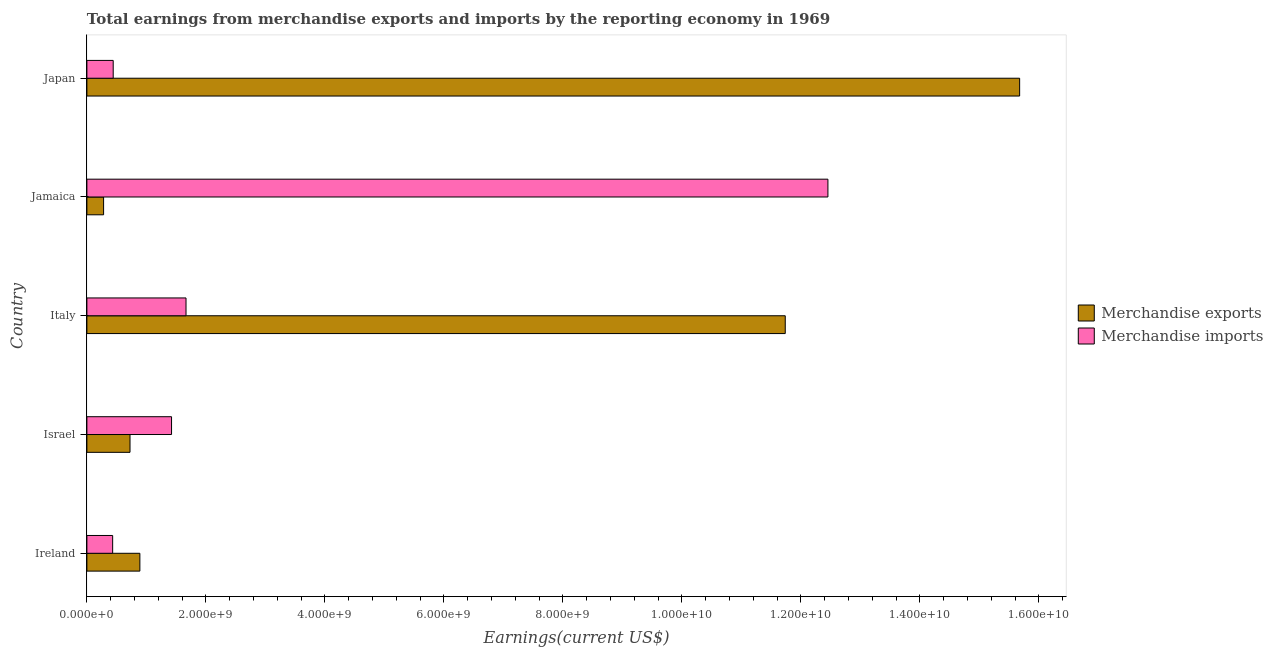How many groups of bars are there?
Provide a succinct answer. 5. Are the number of bars per tick equal to the number of legend labels?
Your response must be concise. Yes. How many bars are there on the 3rd tick from the bottom?
Give a very brief answer. 2. What is the label of the 2nd group of bars from the top?
Provide a succinct answer. Jamaica. In how many cases, is the number of bars for a given country not equal to the number of legend labels?
Make the answer very short. 0. What is the earnings from merchandise imports in Italy?
Provide a succinct answer. 1.67e+09. Across all countries, what is the maximum earnings from merchandise exports?
Your answer should be very brief. 1.57e+1. Across all countries, what is the minimum earnings from merchandise exports?
Offer a terse response. 2.81e+08. In which country was the earnings from merchandise exports minimum?
Provide a succinct answer. Jamaica. What is the total earnings from merchandise imports in the graph?
Provide a short and direct response. 1.64e+1. What is the difference between the earnings from merchandise imports in Ireland and that in Italy?
Keep it short and to the point. -1.23e+09. What is the difference between the earnings from merchandise exports in Japan and the earnings from merchandise imports in Ireland?
Your answer should be very brief. 1.52e+1. What is the average earnings from merchandise imports per country?
Your answer should be very brief. 3.28e+09. What is the difference between the earnings from merchandise imports and earnings from merchandise exports in Ireland?
Your answer should be compact. -4.57e+08. In how many countries, is the earnings from merchandise imports greater than 7200000000 US$?
Make the answer very short. 1. What is the ratio of the earnings from merchandise imports in Israel to that in Japan?
Your answer should be compact. 3.22. Is the earnings from merchandise exports in Jamaica less than that in Japan?
Ensure brevity in your answer.  Yes. What is the difference between the highest and the second highest earnings from merchandise exports?
Your answer should be very brief. 3.94e+09. What is the difference between the highest and the lowest earnings from merchandise exports?
Keep it short and to the point. 1.54e+1. Is the sum of the earnings from merchandise imports in Jamaica and Japan greater than the maximum earnings from merchandise exports across all countries?
Make the answer very short. No. What does the 1st bar from the top in Japan represents?
Make the answer very short. Merchandise imports. How many bars are there?
Keep it short and to the point. 10. Does the graph contain any zero values?
Provide a short and direct response. No. Where does the legend appear in the graph?
Make the answer very short. Center right. How many legend labels are there?
Give a very brief answer. 2. How are the legend labels stacked?
Offer a very short reply. Vertical. What is the title of the graph?
Your answer should be compact. Total earnings from merchandise exports and imports by the reporting economy in 1969. Does "Fertility rate" appear as one of the legend labels in the graph?
Give a very brief answer. No. What is the label or title of the X-axis?
Offer a terse response. Earnings(current US$). What is the label or title of the Y-axis?
Offer a very short reply. Country. What is the Earnings(current US$) of Merchandise exports in Ireland?
Your answer should be compact. 8.90e+08. What is the Earnings(current US$) in Merchandise imports in Ireland?
Provide a succinct answer. 4.33e+08. What is the Earnings(current US$) in Merchandise exports in Israel?
Provide a short and direct response. 7.25e+08. What is the Earnings(current US$) of Merchandise imports in Israel?
Your answer should be compact. 1.42e+09. What is the Earnings(current US$) in Merchandise exports in Italy?
Offer a terse response. 1.17e+1. What is the Earnings(current US$) in Merchandise imports in Italy?
Offer a terse response. 1.67e+09. What is the Earnings(current US$) of Merchandise exports in Jamaica?
Give a very brief answer. 2.81e+08. What is the Earnings(current US$) in Merchandise imports in Jamaica?
Your answer should be very brief. 1.25e+1. What is the Earnings(current US$) in Merchandise exports in Japan?
Ensure brevity in your answer.  1.57e+1. What is the Earnings(current US$) of Merchandise imports in Japan?
Make the answer very short. 4.42e+08. Across all countries, what is the maximum Earnings(current US$) in Merchandise exports?
Offer a very short reply. 1.57e+1. Across all countries, what is the maximum Earnings(current US$) in Merchandise imports?
Offer a terse response. 1.25e+1. Across all countries, what is the minimum Earnings(current US$) in Merchandise exports?
Your answer should be compact. 2.81e+08. Across all countries, what is the minimum Earnings(current US$) of Merchandise imports?
Provide a succinct answer. 4.33e+08. What is the total Earnings(current US$) in Merchandise exports in the graph?
Your answer should be very brief. 2.93e+1. What is the total Earnings(current US$) in Merchandise imports in the graph?
Offer a terse response. 1.64e+1. What is the difference between the Earnings(current US$) of Merchandise exports in Ireland and that in Israel?
Provide a succinct answer. 1.66e+08. What is the difference between the Earnings(current US$) of Merchandise imports in Ireland and that in Israel?
Offer a very short reply. -9.90e+08. What is the difference between the Earnings(current US$) of Merchandise exports in Ireland and that in Italy?
Ensure brevity in your answer.  -1.08e+1. What is the difference between the Earnings(current US$) of Merchandise imports in Ireland and that in Italy?
Your response must be concise. -1.23e+09. What is the difference between the Earnings(current US$) in Merchandise exports in Ireland and that in Jamaica?
Your response must be concise. 6.10e+08. What is the difference between the Earnings(current US$) of Merchandise imports in Ireland and that in Jamaica?
Provide a short and direct response. -1.20e+1. What is the difference between the Earnings(current US$) of Merchandise exports in Ireland and that in Japan?
Your response must be concise. -1.48e+1. What is the difference between the Earnings(current US$) in Merchandise imports in Ireland and that in Japan?
Your response must be concise. -9.01e+06. What is the difference between the Earnings(current US$) of Merchandise exports in Israel and that in Italy?
Keep it short and to the point. -1.10e+1. What is the difference between the Earnings(current US$) of Merchandise imports in Israel and that in Italy?
Make the answer very short. -2.43e+08. What is the difference between the Earnings(current US$) in Merchandise exports in Israel and that in Jamaica?
Provide a succinct answer. 4.44e+08. What is the difference between the Earnings(current US$) in Merchandise imports in Israel and that in Jamaica?
Ensure brevity in your answer.  -1.10e+1. What is the difference between the Earnings(current US$) of Merchandise exports in Israel and that in Japan?
Your response must be concise. -1.50e+1. What is the difference between the Earnings(current US$) of Merchandise imports in Israel and that in Japan?
Provide a succinct answer. 9.81e+08. What is the difference between the Earnings(current US$) of Merchandise exports in Italy and that in Jamaica?
Your response must be concise. 1.15e+1. What is the difference between the Earnings(current US$) in Merchandise imports in Italy and that in Jamaica?
Provide a short and direct response. -1.08e+1. What is the difference between the Earnings(current US$) in Merchandise exports in Italy and that in Japan?
Offer a terse response. -3.94e+09. What is the difference between the Earnings(current US$) of Merchandise imports in Italy and that in Japan?
Your response must be concise. 1.22e+09. What is the difference between the Earnings(current US$) of Merchandise exports in Jamaica and that in Japan?
Give a very brief answer. -1.54e+1. What is the difference between the Earnings(current US$) in Merchandise imports in Jamaica and that in Japan?
Your answer should be very brief. 1.20e+1. What is the difference between the Earnings(current US$) of Merchandise exports in Ireland and the Earnings(current US$) of Merchandise imports in Israel?
Provide a short and direct response. -5.32e+08. What is the difference between the Earnings(current US$) in Merchandise exports in Ireland and the Earnings(current US$) in Merchandise imports in Italy?
Offer a very short reply. -7.76e+08. What is the difference between the Earnings(current US$) of Merchandise exports in Ireland and the Earnings(current US$) of Merchandise imports in Jamaica?
Make the answer very short. -1.16e+1. What is the difference between the Earnings(current US$) in Merchandise exports in Ireland and the Earnings(current US$) in Merchandise imports in Japan?
Your answer should be very brief. 4.48e+08. What is the difference between the Earnings(current US$) of Merchandise exports in Israel and the Earnings(current US$) of Merchandise imports in Italy?
Your answer should be compact. -9.41e+08. What is the difference between the Earnings(current US$) of Merchandise exports in Israel and the Earnings(current US$) of Merchandise imports in Jamaica?
Keep it short and to the point. -1.17e+1. What is the difference between the Earnings(current US$) in Merchandise exports in Israel and the Earnings(current US$) in Merchandise imports in Japan?
Make the answer very short. 2.83e+08. What is the difference between the Earnings(current US$) of Merchandise exports in Italy and the Earnings(current US$) of Merchandise imports in Jamaica?
Your response must be concise. -7.17e+08. What is the difference between the Earnings(current US$) of Merchandise exports in Italy and the Earnings(current US$) of Merchandise imports in Japan?
Keep it short and to the point. 1.13e+1. What is the difference between the Earnings(current US$) of Merchandise exports in Jamaica and the Earnings(current US$) of Merchandise imports in Japan?
Your answer should be compact. -1.61e+08. What is the average Earnings(current US$) in Merchandise exports per country?
Your answer should be very brief. 5.86e+09. What is the average Earnings(current US$) in Merchandise imports per country?
Make the answer very short. 3.28e+09. What is the difference between the Earnings(current US$) in Merchandise exports and Earnings(current US$) in Merchandise imports in Ireland?
Keep it short and to the point. 4.57e+08. What is the difference between the Earnings(current US$) in Merchandise exports and Earnings(current US$) in Merchandise imports in Israel?
Give a very brief answer. -6.98e+08. What is the difference between the Earnings(current US$) in Merchandise exports and Earnings(current US$) in Merchandise imports in Italy?
Provide a succinct answer. 1.01e+1. What is the difference between the Earnings(current US$) in Merchandise exports and Earnings(current US$) in Merchandise imports in Jamaica?
Make the answer very short. -1.22e+1. What is the difference between the Earnings(current US$) in Merchandise exports and Earnings(current US$) in Merchandise imports in Japan?
Your answer should be compact. 1.52e+1. What is the ratio of the Earnings(current US$) in Merchandise exports in Ireland to that in Israel?
Ensure brevity in your answer.  1.23. What is the ratio of the Earnings(current US$) in Merchandise imports in Ireland to that in Israel?
Your response must be concise. 0.3. What is the ratio of the Earnings(current US$) of Merchandise exports in Ireland to that in Italy?
Keep it short and to the point. 0.08. What is the ratio of the Earnings(current US$) of Merchandise imports in Ireland to that in Italy?
Keep it short and to the point. 0.26. What is the ratio of the Earnings(current US$) of Merchandise exports in Ireland to that in Jamaica?
Keep it short and to the point. 3.17. What is the ratio of the Earnings(current US$) in Merchandise imports in Ireland to that in Jamaica?
Offer a very short reply. 0.03. What is the ratio of the Earnings(current US$) of Merchandise exports in Ireland to that in Japan?
Keep it short and to the point. 0.06. What is the ratio of the Earnings(current US$) in Merchandise imports in Ireland to that in Japan?
Offer a very short reply. 0.98. What is the ratio of the Earnings(current US$) of Merchandise exports in Israel to that in Italy?
Provide a succinct answer. 0.06. What is the ratio of the Earnings(current US$) of Merchandise imports in Israel to that in Italy?
Make the answer very short. 0.85. What is the ratio of the Earnings(current US$) of Merchandise exports in Israel to that in Jamaica?
Your response must be concise. 2.58. What is the ratio of the Earnings(current US$) in Merchandise imports in Israel to that in Jamaica?
Ensure brevity in your answer.  0.11. What is the ratio of the Earnings(current US$) of Merchandise exports in Israel to that in Japan?
Ensure brevity in your answer.  0.05. What is the ratio of the Earnings(current US$) of Merchandise imports in Israel to that in Japan?
Give a very brief answer. 3.22. What is the ratio of the Earnings(current US$) of Merchandise exports in Italy to that in Jamaica?
Keep it short and to the point. 41.81. What is the ratio of the Earnings(current US$) in Merchandise imports in Italy to that in Jamaica?
Make the answer very short. 0.13. What is the ratio of the Earnings(current US$) of Merchandise exports in Italy to that in Japan?
Your answer should be very brief. 0.75. What is the ratio of the Earnings(current US$) of Merchandise imports in Italy to that in Japan?
Provide a short and direct response. 3.77. What is the ratio of the Earnings(current US$) of Merchandise exports in Jamaica to that in Japan?
Your answer should be compact. 0.02. What is the ratio of the Earnings(current US$) of Merchandise imports in Jamaica to that in Japan?
Make the answer very short. 28.17. What is the difference between the highest and the second highest Earnings(current US$) of Merchandise exports?
Your answer should be very brief. 3.94e+09. What is the difference between the highest and the second highest Earnings(current US$) in Merchandise imports?
Keep it short and to the point. 1.08e+1. What is the difference between the highest and the lowest Earnings(current US$) in Merchandise exports?
Your answer should be compact. 1.54e+1. What is the difference between the highest and the lowest Earnings(current US$) in Merchandise imports?
Your response must be concise. 1.20e+1. 